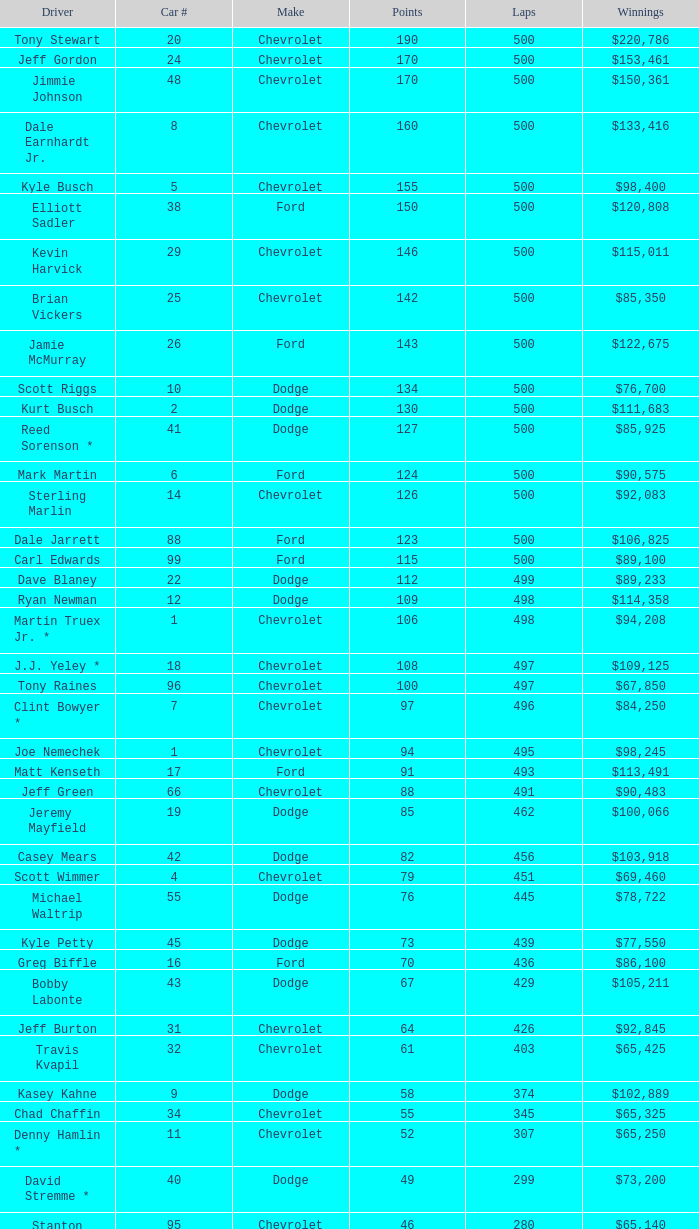What make of car did Brian Vickers drive? Chevrolet. 